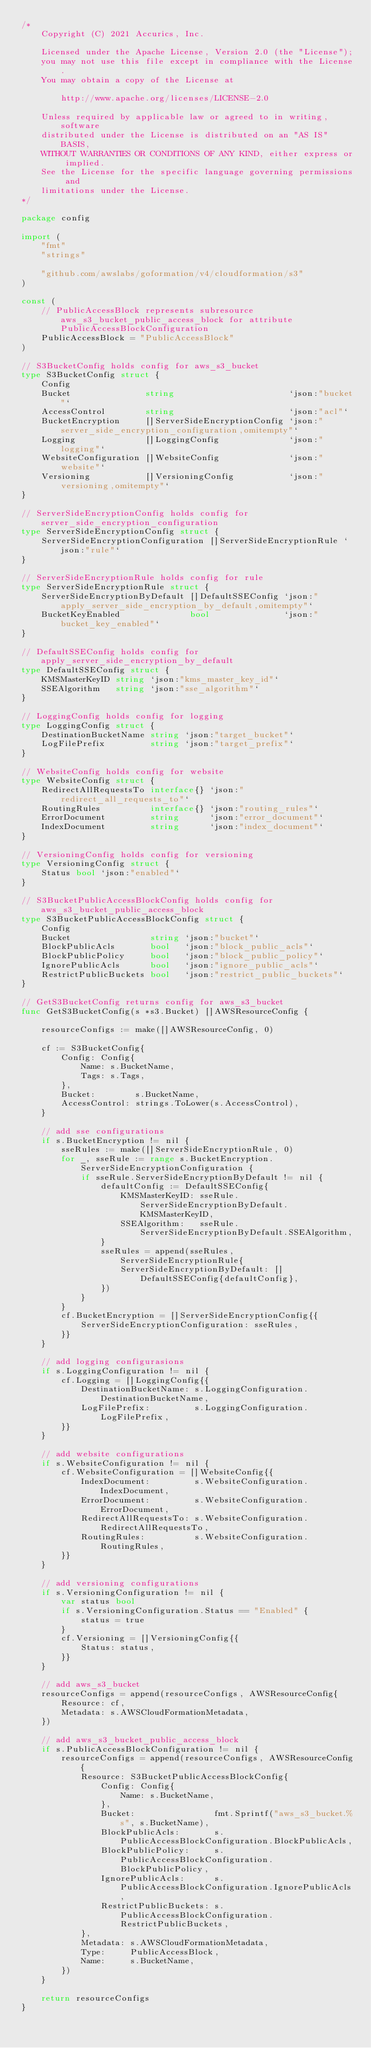<code> <loc_0><loc_0><loc_500><loc_500><_Go_>/*
    Copyright (C) 2021 Accurics, Inc.

	Licensed under the Apache License, Version 2.0 (the "License");
    you may not use this file except in compliance with the License.
    You may obtain a copy of the License at

		http://www.apache.org/licenses/LICENSE-2.0

	Unless required by applicable law or agreed to in writing, software
    distributed under the License is distributed on an "AS IS" BASIS,
    WITHOUT WARRANTIES OR CONDITIONS OF ANY KIND, either express or implied.
    See the License for the specific language governing permissions and
    limitations under the License.
*/

package config

import (
	"fmt"
	"strings"

	"github.com/awslabs/goformation/v4/cloudformation/s3"
)

const (
	// PublicAccessBlock represents subresource aws_s3_bucket_public_access_block for attribute PublicAccessBlockConfiguration
	PublicAccessBlock = "PublicAccessBlock"
)

// S3BucketConfig holds config for aws_s3_bucket
type S3BucketConfig struct {
	Config
	Bucket               string                       `json:"bucket"`
	AccessControl        string                       `json:"acl"`
	BucketEncryption     []ServerSideEncryptionConfig `json:"server_side_encryption_configuration,omitempty"`
	Logging              []LoggingConfig              `json:"logging"`
	WebsiteConfiguration []WebsiteConfig              `json:"website"`
	Versioning           []VersioningConfig           `json:"versioning,omitempty"`
}

// ServerSideEncryptionConfig holds config for server_side_encryption_configuration
type ServerSideEncryptionConfig struct {
	ServerSideEncryptionConfiguration []ServerSideEncryptionRule `json:"rule"`
}

// ServerSideEncryptionRule holds config for rule
type ServerSideEncryptionRule struct {
	ServerSideEncryptionByDefault []DefaultSSEConfig `json:"apply_server_side_encryption_by_default,omitempty"`
	BucketKeyEnabled              bool               `json:"bucket_key_enabled"`
}

// DefaultSSEConfig holds config for apply_server_side_encryption_by_default
type DefaultSSEConfig struct {
	KMSMasterKeyID string `json:"kms_master_key_id"`
	SSEAlgorithm   string `json:"sse_algorithm"`
}

// LoggingConfig holds config for logging
type LoggingConfig struct {
	DestinationBucketName string `json:"target_bucket"`
	LogFilePrefix         string `json:"target_prefix"`
}

// WebsiteConfig holds config for website
type WebsiteConfig struct {
	RedirectAllRequestsTo interface{} `json:"redirect_all_requests_to"`
	RoutingRules          interface{} `json:"routing_rules"`
	ErrorDocument         string      `json:"error_document"`
	IndexDocument         string      `json:"index_document"`
}

// VersioningConfig holds config for versioning
type VersioningConfig struct {
	Status bool `json:"enabled"`
}

// S3BucketPublicAccessBlockConfig holds config for aws_s3_bucket_public_access_block
type S3BucketPublicAccessBlockConfig struct {
	Config
	Bucket                string `json:"bucket"`
	BlockPublicAcls       bool   `json:"block_public_acls"`
	BlockPublicPolicy     bool   `json:"block_public_policy"`
	IgnorePublicAcls      bool   `json:"ignore_public_acls"`
	RestrictPublicBuckets bool   `json:"restrict_public_buckets"`
}

// GetS3BucketConfig returns config for aws_s3_bucket
func GetS3BucketConfig(s *s3.Bucket) []AWSResourceConfig {

	resourceConfigs := make([]AWSResourceConfig, 0)

	cf := S3BucketConfig{
		Config: Config{
			Name: s.BucketName,
			Tags: s.Tags,
		},
		Bucket:        s.BucketName,
		AccessControl: strings.ToLower(s.AccessControl),
	}

	// add sse configurations
	if s.BucketEncryption != nil {
		sseRules := make([]ServerSideEncryptionRule, 0)
		for _, sseRule := range s.BucketEncryption.ServerSideEncryptionConfiguration {
			if sseRule.ServerSideEncryptionByDefault != nil {
				defaultConfig := DefaultSSEConfig{
					KMSMasterKeyID: sseRule.ServerSideEncryptionByDefault.KMSMasterKeyID,
					SSEAlgorithm:   sseRule.ServerSideEncryptionByDefault.SSEAlgorithm,
				}
				sseRules = append(sseRules, ServerSideEncryptionRule{
					ServerSideEncryptionByDefault: []DefaultSSEConfig{defaultConfig},
				})
			}
		}
		cf.BucketEncryption = []ServerSideEncryptionConfig{{
			ServerSideEncryptionConfiguration: sseRules,
		}}
	}

	// add logging configurasions
	if s.LoggingConfiguration != nil {
		cf.Logging = []LoggingConfig{{
			DestinationBucketName: s.LoggingConfiguration.DestinationBucketName,
			LogFilePrefix:         s.LoggingConfiguration.LogFilePrefix,
		}}
	}

	// add website configurations
	if s.WebsiteConfiguration != nil {
		cf.WebsiteConfiguration = []WebsiteConfig{{
			IndexDocument:         s.WebsiteConfiguration.IndexDocument,
			ErrorDocument:         s.WebsiteConfiguration.ErrorDocument,
			RedirectAllRequestsTo: s.WebsiteConfiguration.RedirectAllRequestsTo,
			RoutingRules:          s.WebsiteConfiguration.RoutingRules,
		}}
	}

	// add versioning configurations
	if s.VersioningConfiguration != nil {
		var status bool
		if s.VersioningConfiguration.Status == "Enabled" {
			status = true
		}
		cf.Versioning = []VersioningConfig{{
			Status: status,
		}}
	}

	// add aws_s3_bucket
	resourceConfigs = append(resourceConfigs, AWSResourceConfig{
		Resource: cf,
		Metadata: s.AWSCloudFormationMetadata,
	})

	// add aws_s3_bucket_public_access_block
	if s.PublicAccessBlockConfiguration != nil {
		resourceConfigs = append(resourceConfigs, AWSResourceConfig{
			Resource: S3BucketPublicAccessBlockConfig{
				Config: Config{
					Name: s.BucketName,
				},
				Bucket:                fmt.Sprintf("aws_s3_bucket.%s", s.BucketName),
				BlockPublicAcls:       s.PublicAccessBlockConfiguration.BlockPublicAcls,
				BlockPublicPolicy:     s.PublicAccessBlockConfiguration.BlockPublicPolicy,
				IgnorePublicAcls:      s.PublicAccessBlockConfiguration.IgnorePublicAcls,
				RestrictPublicBuckets: s.PublicAccessBlockConfiguration.RestrictPublicBuckets,
			},
			Metadata: s.AWSCloudFormationMetadata,
			Type:     PublicAccessBlock,
			Name:     s.BucketName,
		})
	}

	return resourceConfigs
}
</code> 